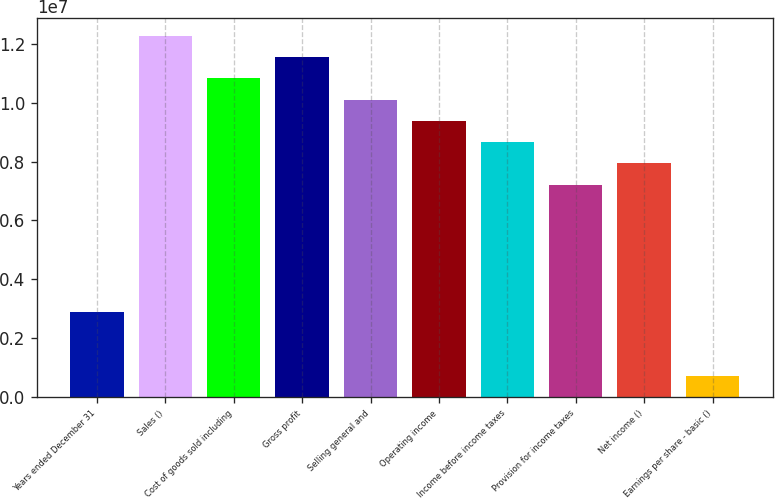<chart> <loc_0><loc_0><loc_500><loc_500><bar_chart><fcel>Years ended December 31<fcel>Sales ()<fcel>Cost of goods sold including<fcel>Gross profit<fcel>Selling general and<fcel>Operating income<fcel>Income before income taxes<fcel>Provision for income taxes<fcel>Net income ()<fcel>Earnings per share - basic ()<nl><fcel>2.88644e+06<fcel>1.22673e+07<fcel>1.08241e+07<fcel>1.15457e+07<fcel>1.01025e+07<fcel>9.3809e+06<fcel>8.6593e+06<fcel>7.21608e+06<fcel>7.93769e+06<fcel>721615<nl></chart> 